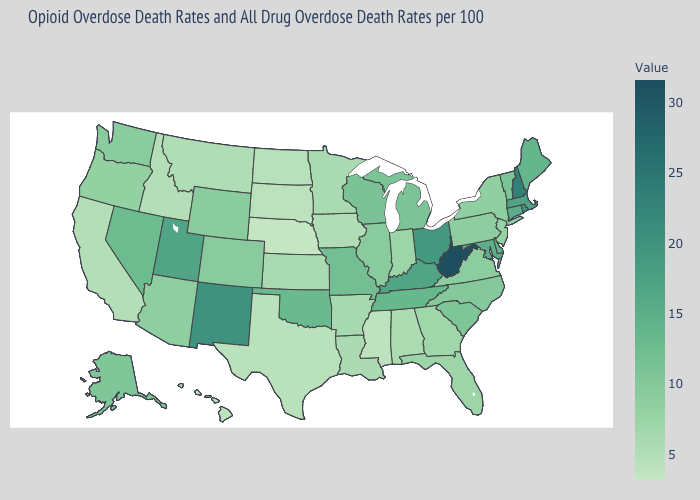Which states have the lowest value in the Northeast?
Keep it brief. New Jersey. Among the states that border North Carolina , does Tennessee have the highest value?
Be succinct. Yes. Among the states that border New York , does New Jersey have the lowest value?
Short answer required. Yes. Does New Jersey have the lowest value in the Northeast?
Write a very short answer. Yes. Does West Virginia have the highest value in the South?
Be succinct. Yes. Which states have the lowest value in the West?
Be succinct. Hawaii. Among the states that border Kentucky , which have the highest value?
Be succinct. West Virginia. 